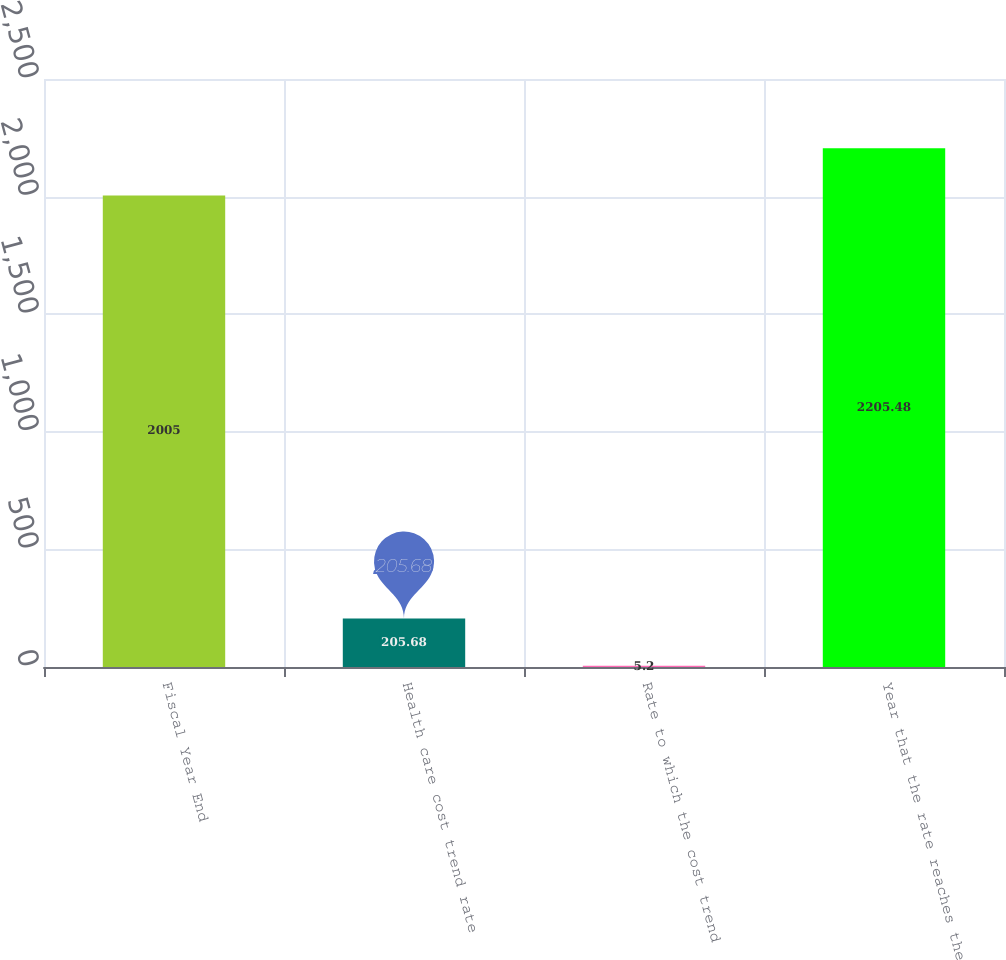Convert chart. <chart><loc_0><loc_0><loc_500><loc_500><bar_chart><fcel>Fiscal Year End<fcel>Health care cost trend rate<fcel>Rate to which the cost trend<fcel>Year that the rate reaches the<nl><fcel>2005<fcel>205.68<fcel>5.2<fcel>2205.48<nl></chart> 